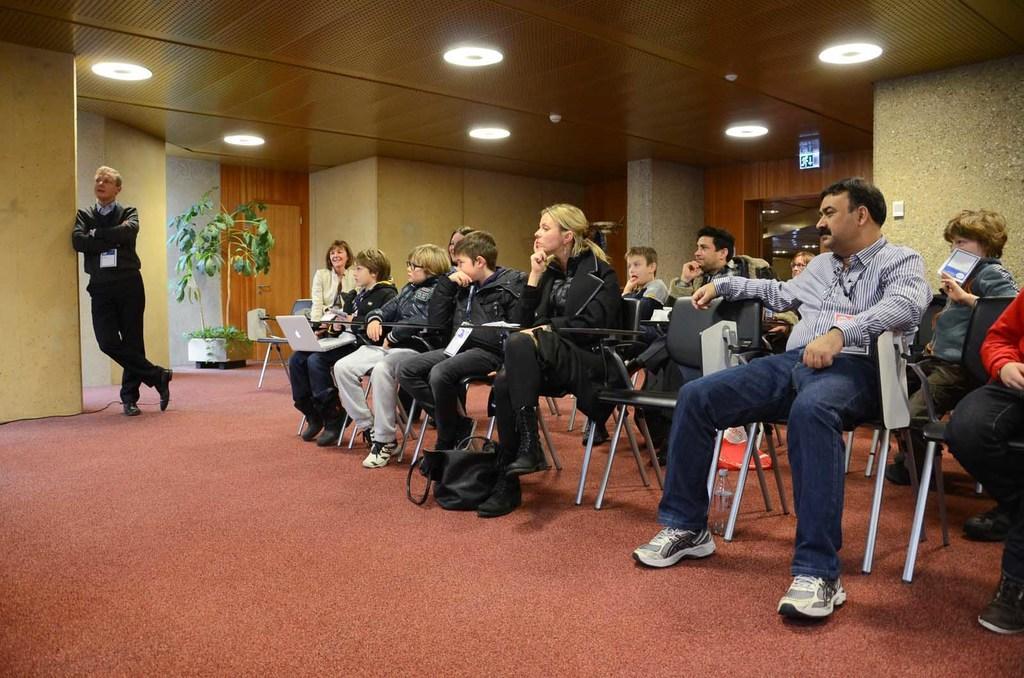Can you describe this image briefly? In this image I can see people are sitting on chairs. In the background I can see wall, a plant and lights on the ceiling. Here I can see a man is standing. 